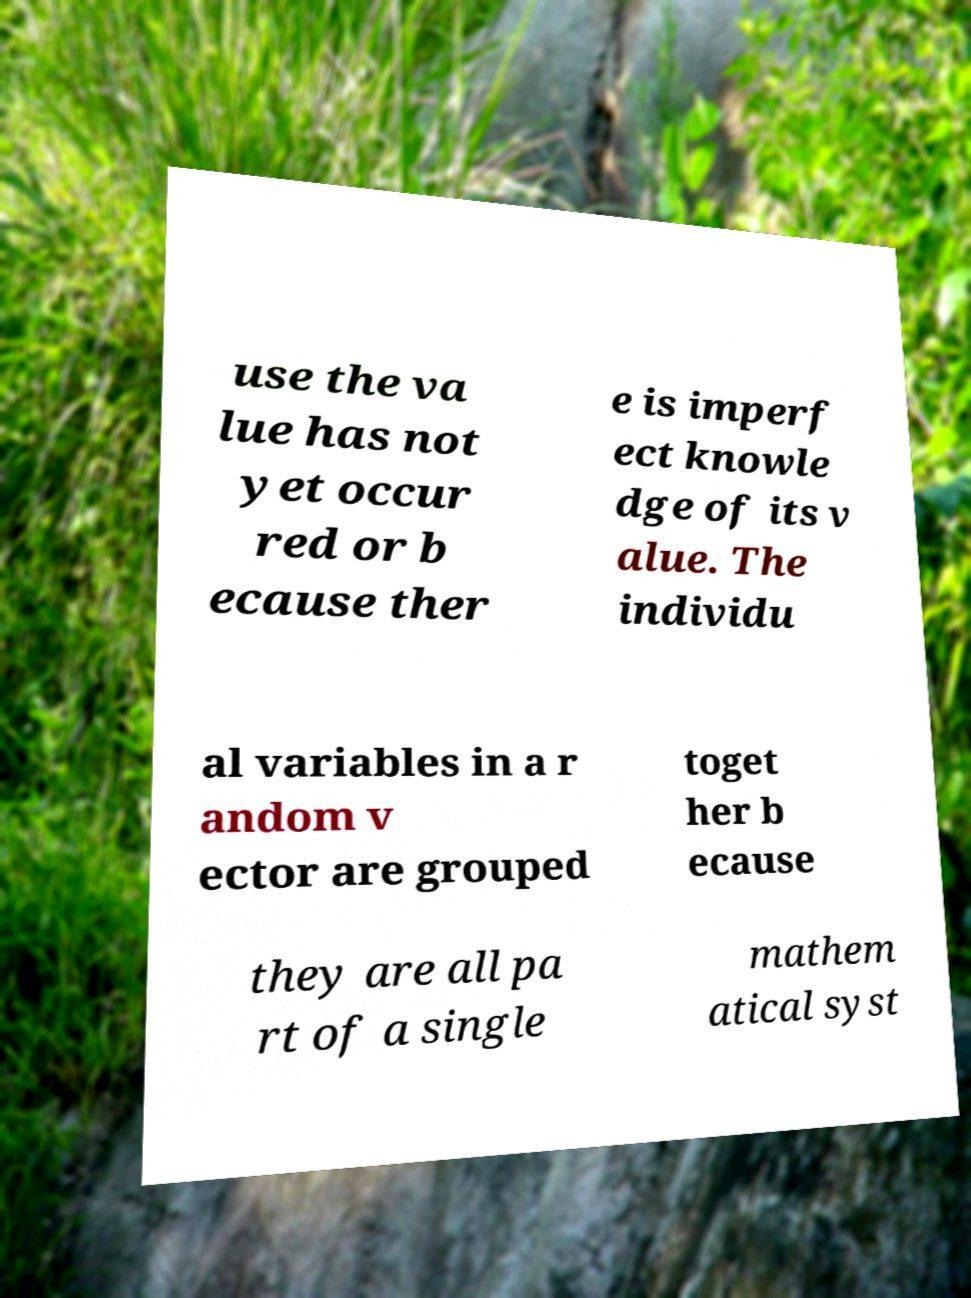For documentation purposes, I need the text within this image transcribed. Could you provide that? use the va lue has not yet occur red or b ecause ther e is imperf ect knowle dge of its v alue. The individu al variables in a r andom v ector are grouped toget her b ecause they are all pa rt of a single mathem atical syst 